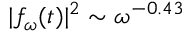<formula> <loc_0><loc_0><loc_500><loc_500>| f _ { \omega } ( t ) | ^ { 2 } \sim \omega ^ { - 0 . 4 3 }</formula> 